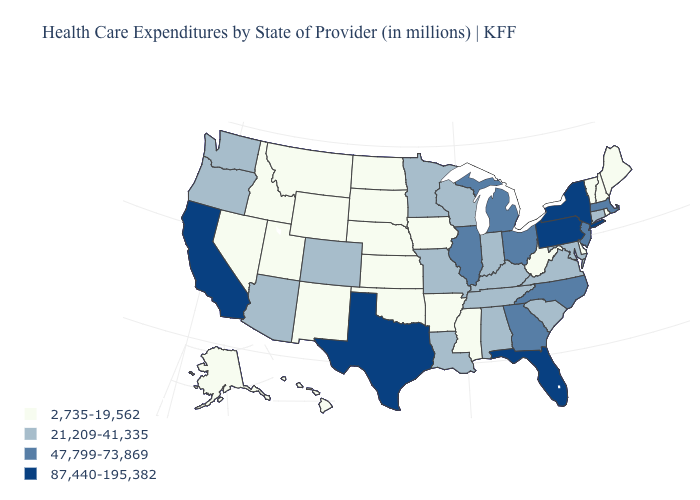Which states have the highest value in the USA?
Concise answer only. California, Florida, New York, Pennsylvania, Texas. Which states have the lowest value in the USA?
Keep it brief. Alaska, Arkansas, Delaware, Hawaii, Idaho, Iowa, Kansas, Maine, Mississippi, Montana, Nebraska, Nevada, New Hampshire, New Mexico, North Dakota, Oklahoma, Rhode Island, South Dakota, Utah, Vermont, West Virginia, Wyoming. What is the value of Utah?
Concise answer only. 2,735-19,562. Name the states that have a value in the range 47,799-73,869?
Concise answer only. Georgia, Illinois, Massachusetts, Michigan, New Jersey, North Carolina, Ohio. Which states have the lowest value in the USA?
Concise answer only. Alaska, Arkansas, Delaware, Hawaii, Idaho, Iowa, Kansas, Maine, Mississippi, Montana, Nebraska, Nevada, New Hampshire, New Mexico, North Dakota, Oklahoma, Rhode Island, South Dakota, Utah, Vermont, West Virginia, Wyoming. Name the states that have a value in the range 47,799-73,869?
Concise answer only. Georgia, Illinois, Massachusetts, Michigan, New Jersey, North Carolina, Ohio. What is the value of North Dakota?
Concise answer only. 2,735-19,562. What is the highest value in states that border Maine?
Short answer required. 2,735-19,562. Does California have the highest value in the West?
Answer briefly. Yes. Name the states that have a value in the range 47,799-73,869?
Quick response, please. Georgia, Illinois, Massachusetts, Michigan, New Jersey, North Carolina, Ohio. Which states hav the highest value in the South?
Be succinct. Florida, Texas. What is the lowest value in states that border South Dakota?
Short answer required. 2,735-19,562. Name the states that have a value in the range 47,799-73,869?
Answer briefly. Georgia, Illinois, Massachusetts, Michigan, New Jersey, North Carolina, Ohio. What is the value of Mississippi?
Answer briefly. 2,735-19,562. Which states have the highest value in the USA?
Concise answer only. California, Florida, New York, Pennsylvania, Texas. 